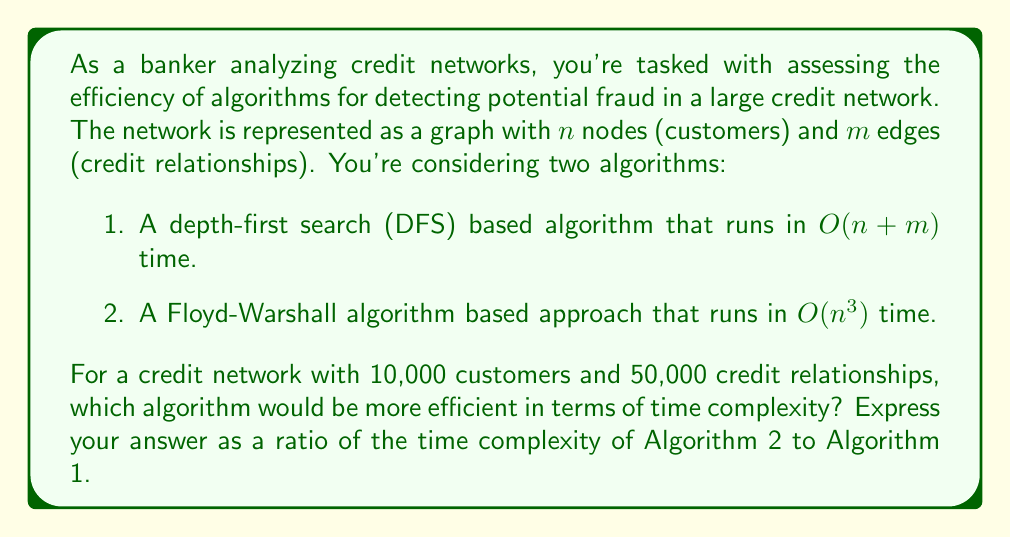Help me with this question. To solve this problem, we need to:

1. Determine the time complexity of each algorithm for the given input.
2. Calculate the ratio of these complexities.

For Algorithm 1 (DFS-based):
- Time complexity: $O(n + m)$
- With $n = 10,000$ and $m = 50,000$, we have:
  $O(10,000 + 50,000) = O(60,000)$

For Algorithm 2 (Floyd-Warshall based):
- Time complexity: $O(n^3)$
- With $n = 10,000$, we have:
  $O(10,000^3) = O(1,000,000,000,000)$

To find the ratio, we divide the complexity of Algorithm 2 by Algorithm 1:

$$\frac{O(1,000,000,000,000)}{O(60,000)} = \frac{1,000,000,000,000}{60,000} = 16,666,666.67$$

This ratio indicates that Algorithm 2 is approximately 16,666,666.67 times slower than Algorithm 1 for the given input size.
Answer: 16,666,666.67 